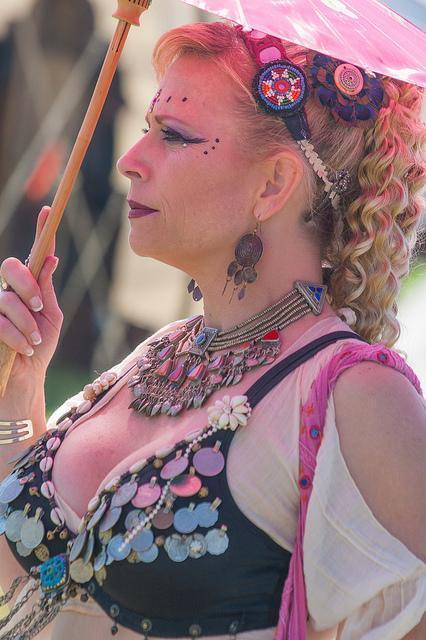How many cups are empty on the table?
Give a very brief answer. 0. 